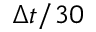<formula> <loc_0><loc_0><loc_500><loc_500>\Delta t / 3 0</formula> 